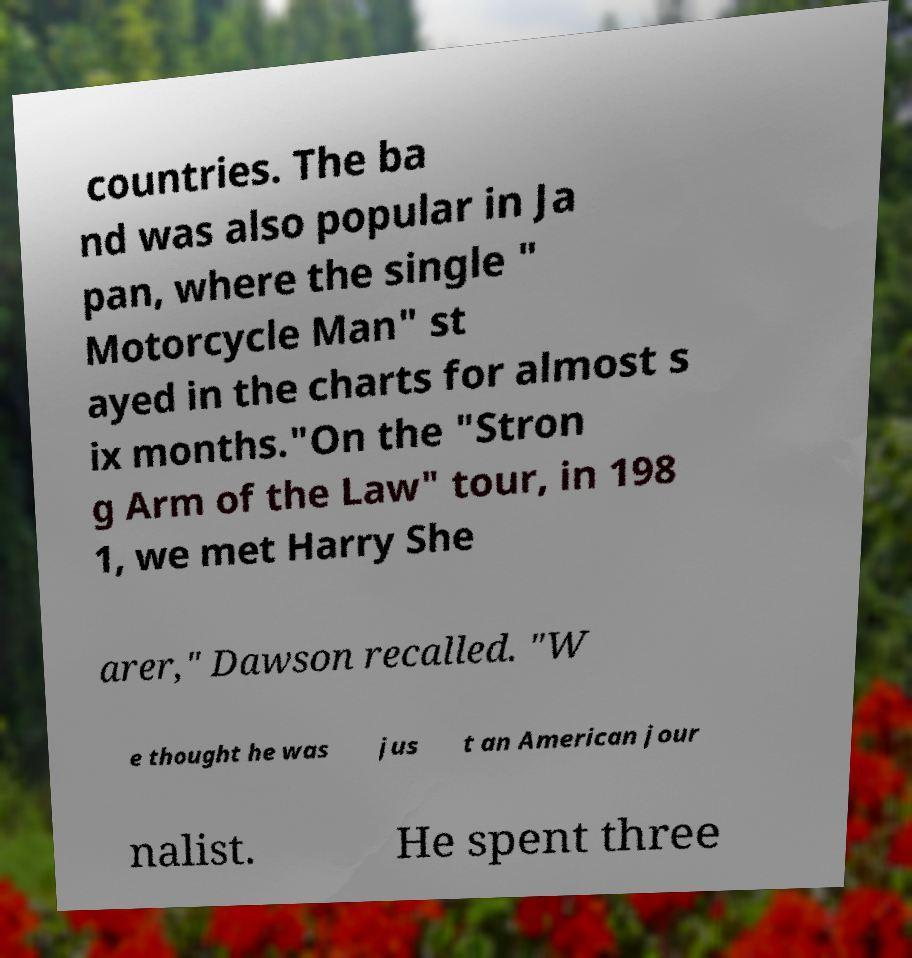There's text embedded in this image that I need extracted. Can you transcribe it verbatim? countries. The ba nd was also popular in Ja pan, where the single " Motorcycle Man" st ayed in the charts for almost s ix months."On the "Stron g Arm of the Law" tour, in 198 1, we met Harry She arer," Dawson recalled. "W e thought he was jus t an American jour nalist. He spent three 